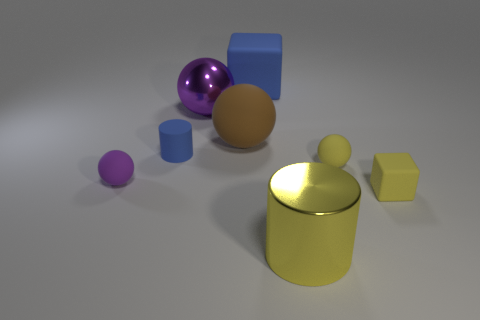Do the rubber cylinder and the rubber object that is behind the large purple shiny object have the same color?
Ensure brevity in your answer.  Yes. Is there another metal object that has the same size as the purple metal object?
Your answer should be very brief. Yes. What material is the small sphere left of the cylinder that is in front of the blue matte cylinder made of?
Your answer should be very brief. Rubber. What number of rubber objects are the same color as the big shiny sphere?
Keep it short and to the point. 1. What is the shape of the purple thing that is made of the same material as the brown sphere?
Provide a succinct answer. Sphere. What size is the blue thing that is behind the large brown sphere?
Provide a succinct answer. Large. Are there an equal number of blue objects that are to the right of the yellow rubber sphere and purple rubber balls left of the metallic sphere?
Provide a succinct answer. No. There is a metallic object that is behind the yellow matte object behind the small rubber sphere left of the big yellow cylinder; what is its color?
Offer a terse response. Purple. What number of things are right of the metallic ball and in front of the big brown sphere?
Keep it short and to the point. 3. There is a small ball on the right side of the matte cylinder; does it have the same color as the matte cube that is on the right side of the big cylinder?
Give a very brief answer. Yes. 